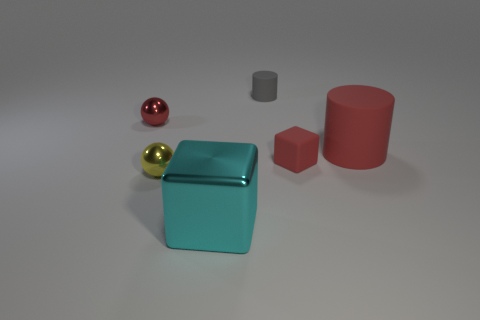Is the number of gray objects in front of the tiny yellow sphere less than the number of red matte objects?
Give a very brief answer. Yes. Does the matte block that is on the left side of the red rubber cylinder have the same size as the gray rubber object?
Your answer should be compact. Yes. What number of objects are in front of the gray rubber thing and left of the tiny red matte block?
Provide a succinct answer. 3. There is a metal ball to the left of the tiny metal thing that is in front of the large red object; what size is it?
Provide a short and direct response. Small. Is the number of yellow shiny spheres to the right of the small yellow sphere less than the number of small gray matte things on the left side of the tiny gray rubber cylinder?
Keep it short and to the point. No. Does the block that is to the right of the cyan thing have the same color as the rubber cylinder that is on the left side of the small red matte object?
Offer a terse response. No. There is a object that is behind the large red rubber cylinder and to the left of the gray cylinder; what is its material?
Offer a terse response. Metal. Are there any big brown balls?
Provide a short and direct response. No. There is a tiny red thing that is made of the same material as the big cube; what shape is it?
Your response must be concise. Sphere. There is a big red thing; does it have the same shape as the red thing on the left side of the small red rubber object?
Give a very brief answer. No. 